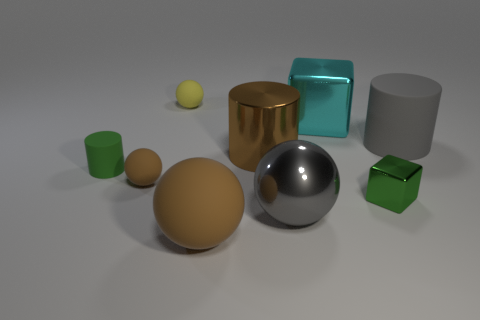Is the number of large gray cylinders greater than the number of gray metal cubes?
Provide a short and direct response. Yes. There is a cylinder that is the same size as the yellow thing; what is its material?
Give a very brief answer. Rubber. Do the cylinder that is in front of the brown cylinder and the tiny brown sphere have the same size?
Make the answer very short. Yes. How many spheres are green things or tiny green shiny things?
Make the answer very short. 0. What is the material of the small green thing behind the small green metal thing?
Give a very brief answer. Rubber. Is the number of large gray objects less than the number of cyan blocks?
Make the answer very short. No. What size is the thing that is to the right of the cyan block and in front of the brown cylinder?
Your answer should be very brief. Small. There is a matte thing on the right side of the large gray thing that is in front of the big gray cylinder that is behind the small matte cylinder; how big is it?
Offer a terse response. Large. How many other things are the same color as the metal ball?
Give a very brief answer. 1. There is a matte object that is to the right of the large shiny cylinder; does it have the same color as the tiny rubber cylinder?
Provide a short and direct response. No. 